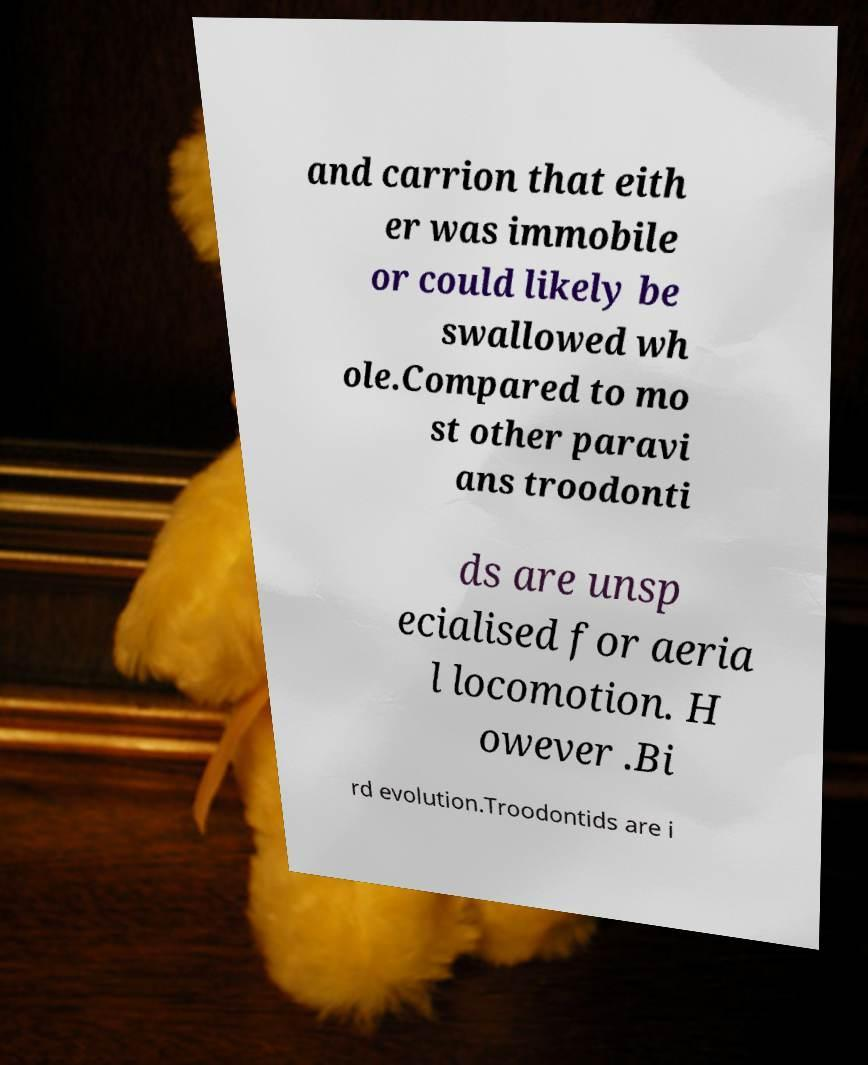I need the written content from this picture converted into text. Can you do that? and carrion that eith er was immobile or could likely be swallowed wh ole.Compared to mo st other paravi ans troodonti ds are unsp ecialised for aeria l locomotion. H owever .Bi rd evolution.Troodontids are i 